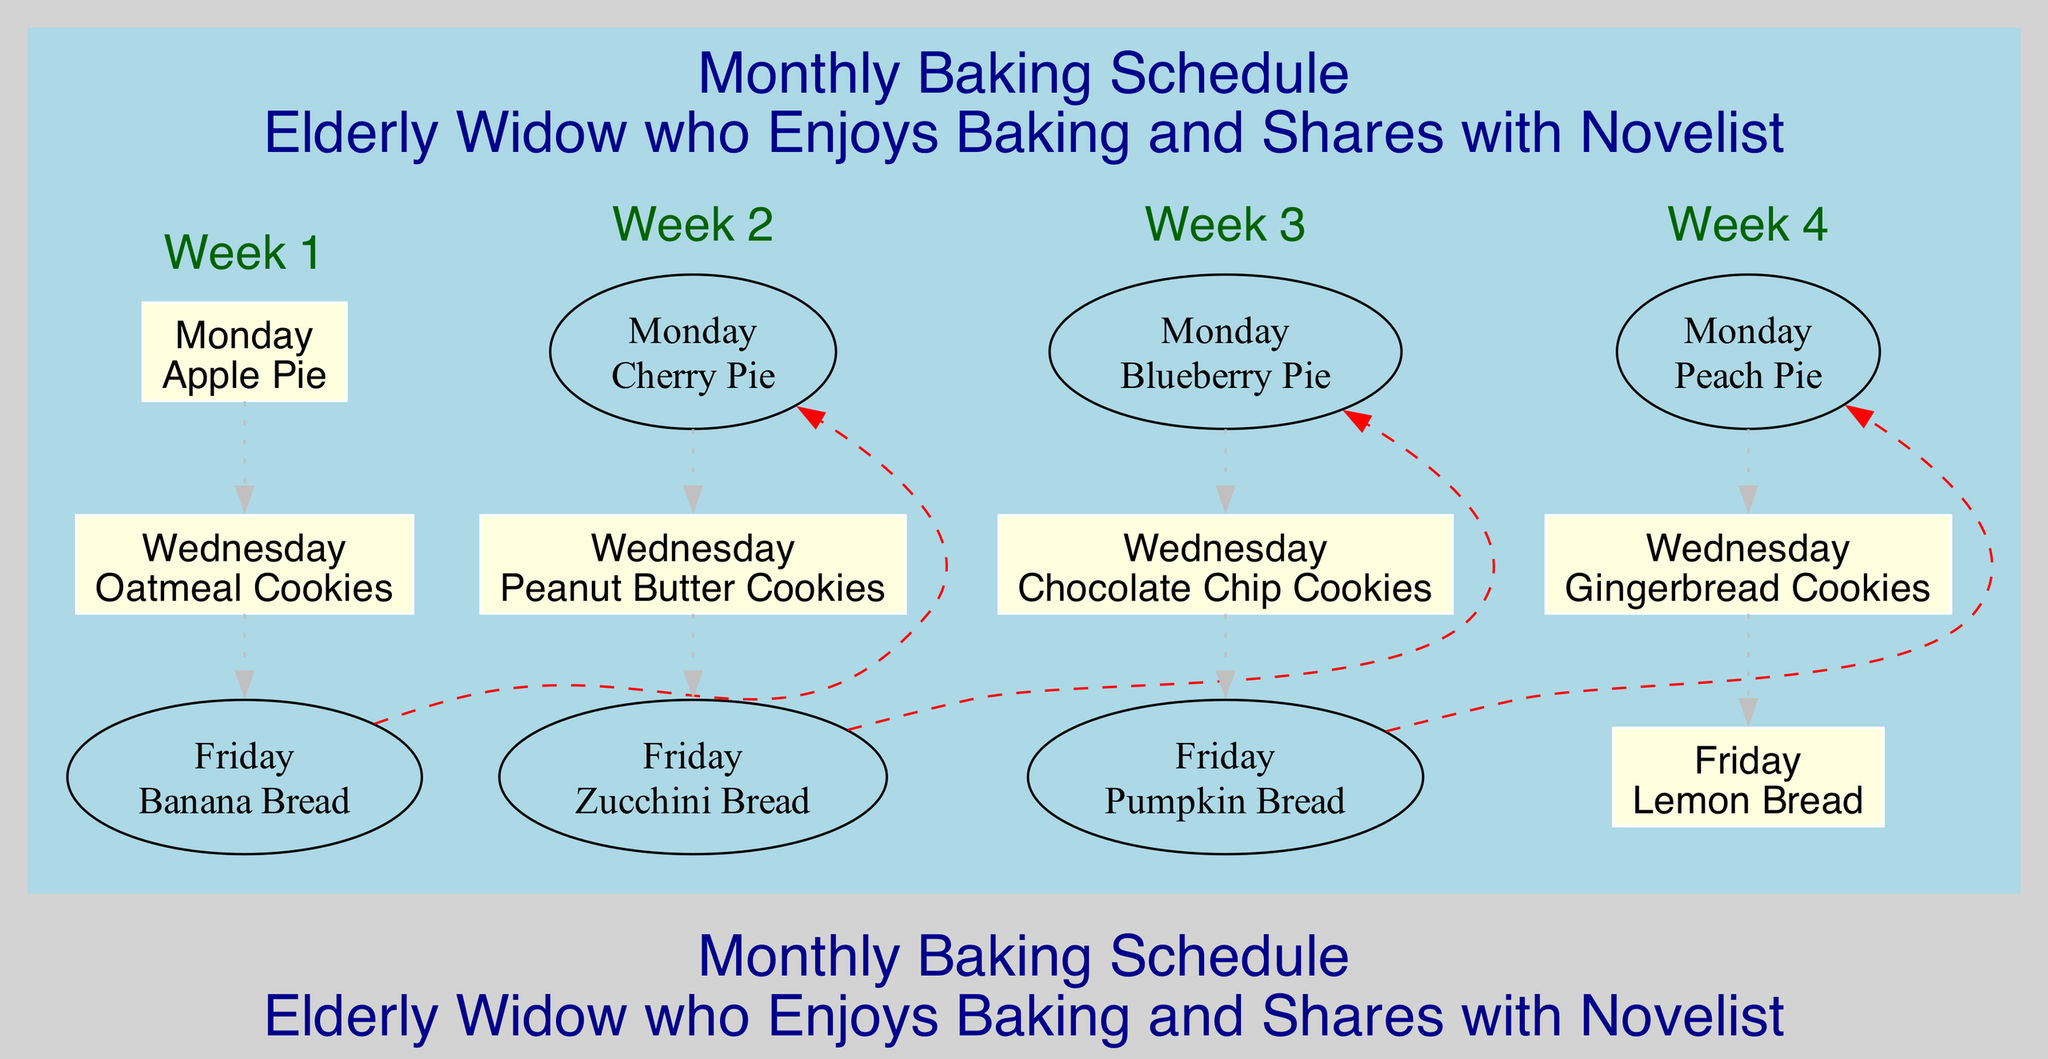What baked good is made on the first Monday? The diagram shows that on the first Monday (Week 1), the baked good is Apple Pie.
Answer: Apple Pie How many different baked goods are there in total? To find the total, count each unique baked good from all weeks: Apple Pie, Oatmeal Cookies, Banana Bread, Cherry Pie, Peanut Butter Cookies, Zucchini Bread, Blueberry Pie, Chocolate Chip Cookies, Pumpkin Bread, Peach Pie, Gingerbread Cookies, and Lemon Bread. There are 12 different baked goods.
Answer: 12 What is the baked good for the last Friday of the month? Looking at the diagram, the last Friday (Week 4) indicates the baked good is Lemon Bread.
Answer: Lemon Bread Which baked good occurs on the second Wednesday? Identifying the second week, the baked good on the second Wednesday is Peanut Butter Cookies.
Answer: Peanut Butter Cookies Is there a baked good that is made on both a Monday and a Wednesday? By examining the schedule, Apple Pie (Week 1) is made on Monday, while Oatmeal Cookies are made on Wednesday of the same week. Thus, yes, there are baked goods made on both days.
Answer: Yes What is the relationship between the last day of Week 1 and the first day of Week 2? In the diagram, the last day of Week 1 is Friday with Banana Bread, and it is connected by a dashed edge to the first day of Week 2, which is Monday with Cherry Pie. This indicates a sequential relationship between the two weeks.
Answer: Sequential What baked goods are made on Wednesdays? Reviewing the diagram, the baked goods made on Wednesdays are: Oatmeal Cookies (Week 1), Peanut Butter Cookies (Week 2), Chocolate Chip Cookies (Week 3), and Gingerbread Cookies (Week 4).
Answer: Oatmeal Cookies, Peanut Butter Cookies, Chocolate Chip Cookies, Gingerbread Cookies How many days are there in the entire baking schedule? Each week contains 3 baking days, and there are 4 weeks, thus the total number of baking days is 3 multiplied by 4, which is 12 days.
Answer: 12 Which week features Pumpkin Bread? After checking the diagram, Pumpkin Bread is featured in Week 3, specifically on Friday.
Answer: Week 3 